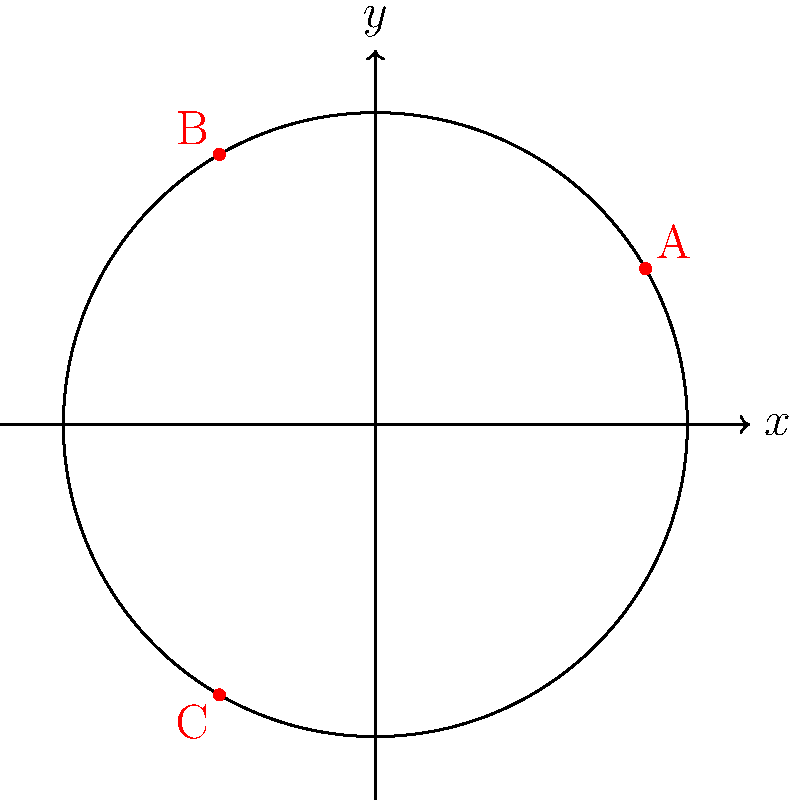In a circular set for a scene with Adria Arjona, three key lights are positioned at points A, B, and C on the perimeter. Given that the set has a radius of 5 meters and light A is at $(\frac{\pi}{6})$ radians, calculate the polar coordinates $(r,\theta)$ for lights B and C to achieve optimal lighting balance. To solve this problem, we need to understand that the lights are evenly distributed around the circular set for optimal balance. Here's the step-by-step solution:

1) The circle represents a full rotation of $2\pi$ radians.

2) For even distribution, the three lights should be placed $\frac{2\pi}{3}$ radians apart.

3) We're given that light A is at $\frac{\pi}{6}$ radians.

4) To find the position of light B, we add $\frac{2\pi}{3}$ to A's position:
   $\frac{\pi}{6} + \frac{2\pi}{3} = \frac{\pi}{6} + \frac{4\pi}{6} = \frac{5\pi}{6} = \frac{2\pi}{3}$ radians

5) For light C, we add another $\frac{2\pi}{3}$:
   $\frac{2\pi}{3} + \frac{2\pi}{3} = \frac{4\pi}{3}$ radians

6) The radius (r) for all lights is 5 meters, as given in the question.

Therefore, the polar coordinates $(r,\theta)$ are:
- Light A: $(5, \frac{\pi}{6})$ (given)
- Light B: $(5, \frac{2\pi}{3})$
- Light C: $(5, \frac{4\pi}{3})$
Answer: B: $(5, \frac{2\pi}{3})$, C: $(5, \frac{4\pi}{3})$ 